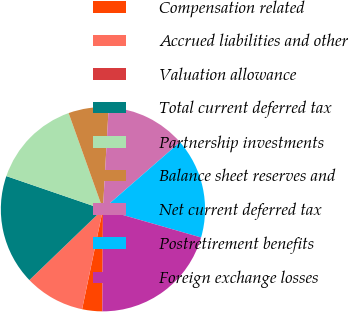Convert chart. <chart><loc_0><loc_0><loc_500><loc_500><pie_chart><fcel>Compensation related<fcel>Accrued liabilities and other<fcel>Valuation allowance<fcel>Total current deferred tax<fcel>Partnership investments<fcel>Balance sheet reserves and<fcel>Net current deferred tax<fcel>Postretirement benefits<fcel>Foreign exchange losses<nl><fcel>3.18%<fcel>9.52%<fcel>0.01%<fcel>17.46%<fcel>14.28%<fcel>6.35%<fcel>12.7%<fcel>15.87%<fcel>20.63%<nl></chart> 